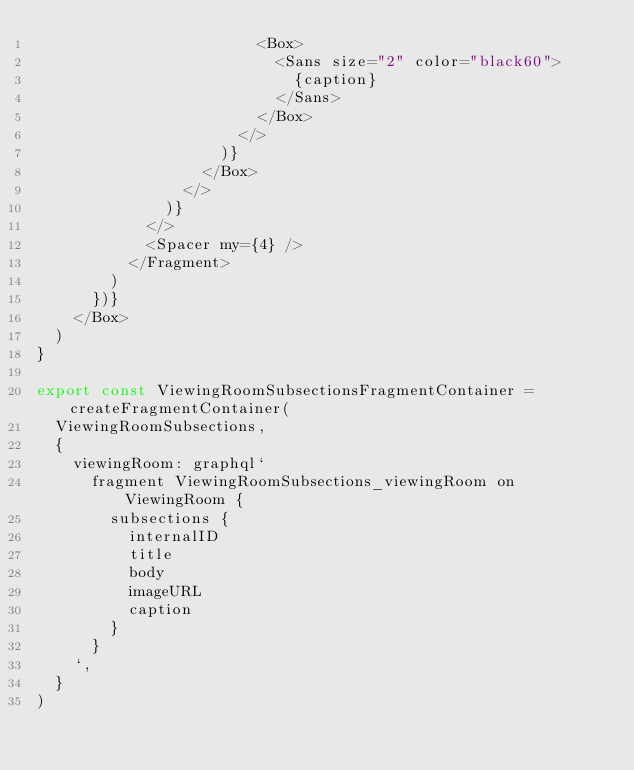Convert code to text. <code><loc_0><loc_0><loc_500><loc_500><_TypeScript_>                        <Box>
                          <Sans size="2" color="black60">
                            {caption}
                          </Sans>
                        </Box>
                      </>
                    )}
                  </Box>
                </>
              )}
            </>
            <Spacer my={4} />
          </Fragment>
        )
      })}
    </Box>
  )
}

export const ViewingRoomSubsectionsFragmentContainer = createFragmentContainer(
  ViewingRoomSubsections,
  {
    viewingRoom: graphql`
      fragment ViewingRoomSubsections_viewingRoom on ViewingRoom {
        subsections {
          internalID
          title
          body
          imageURL
          caption
        }
      }
    `,
  }
)
</code> 